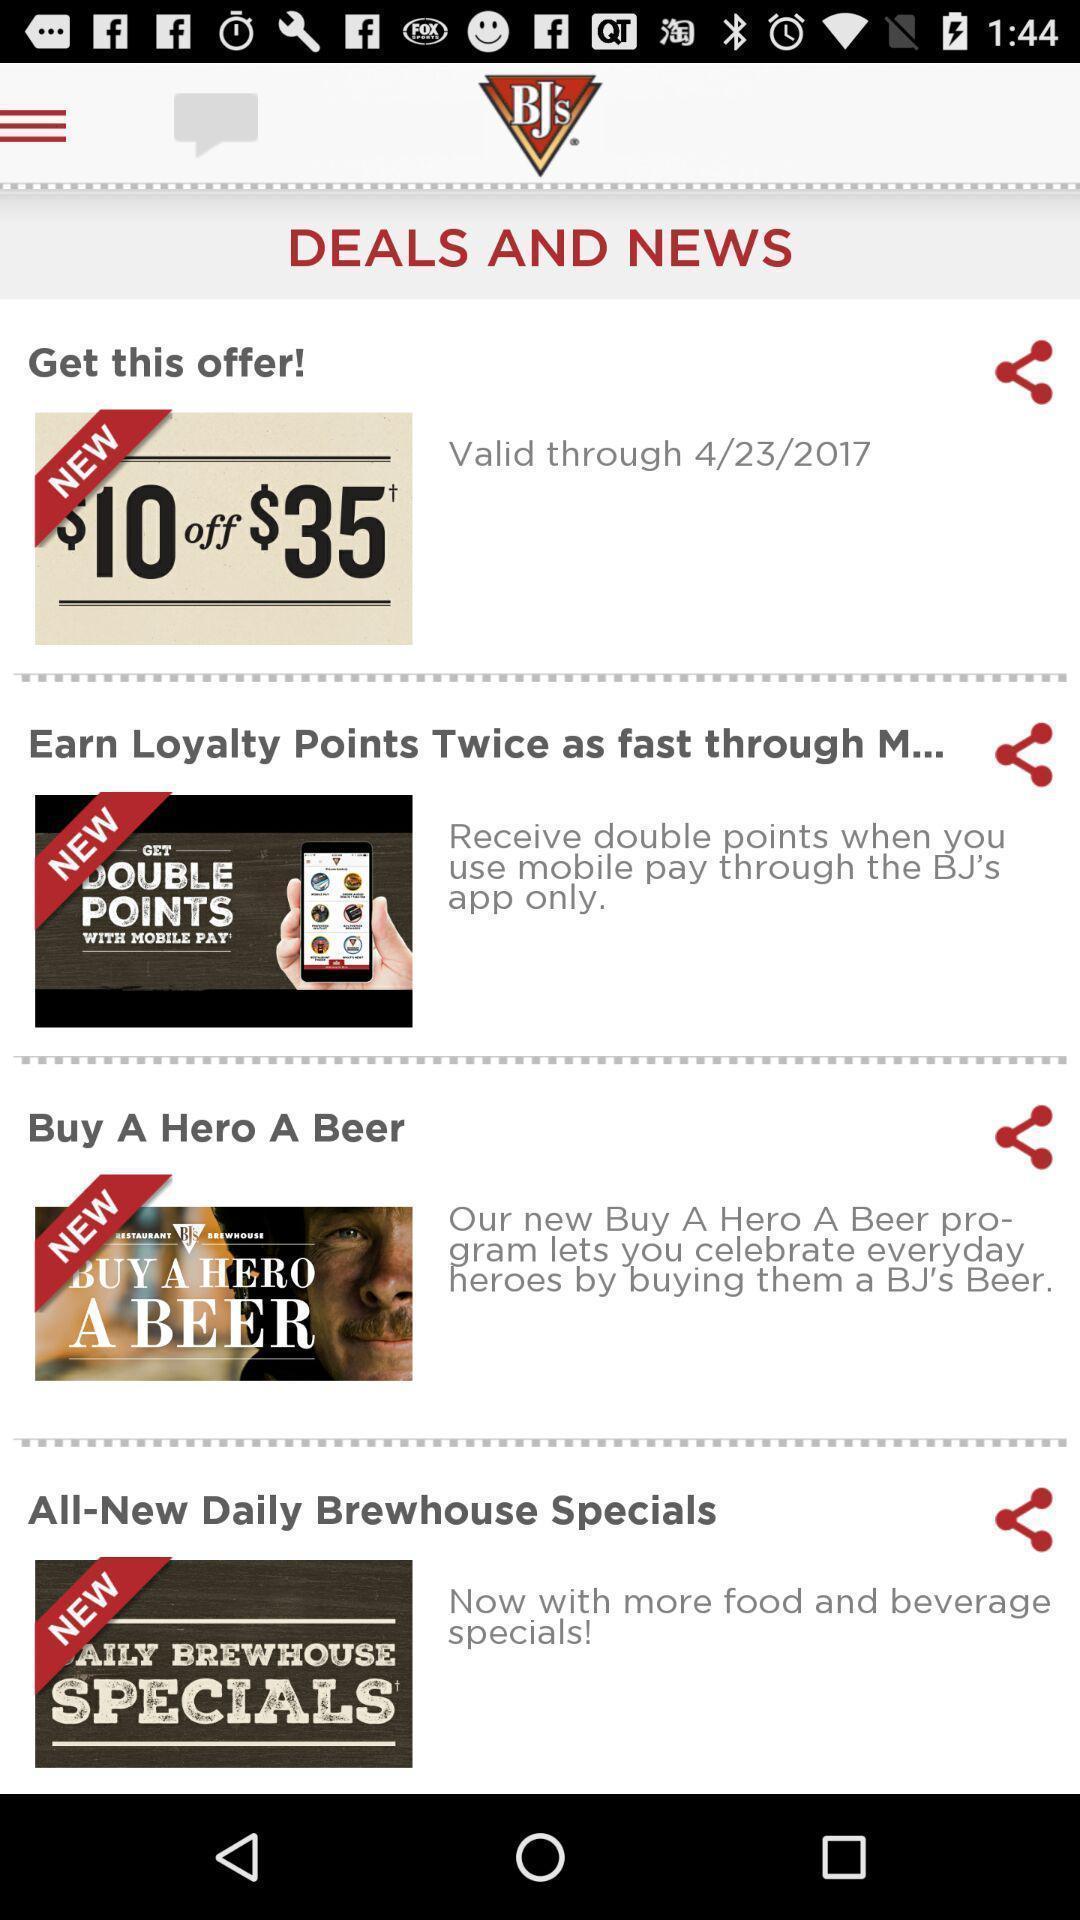Summarize the main components in this picture. Screen displaying a list of offers with share option. 